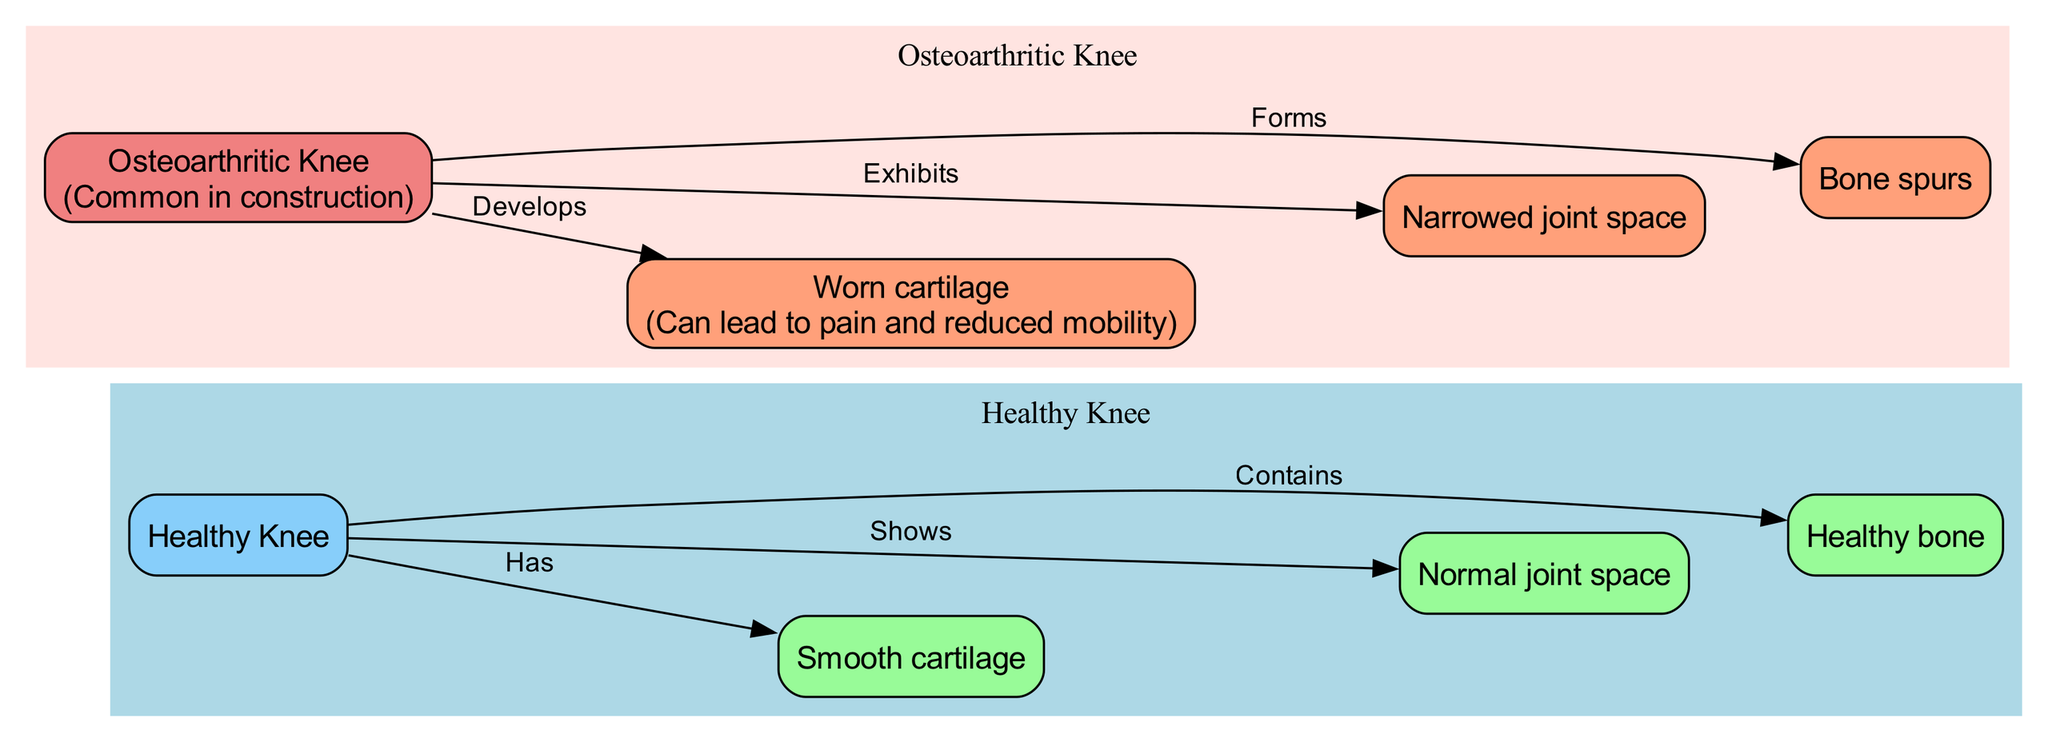What does the healthy knee contain? The diagram indicates that the healthy knee contains healthy bone, represented by the connection from "Healthy Knee" to "Healthy bone" that states "Contains".
Answer: Healthy bone What condition does an osteoarthritic knee develop? The diagram shows that the osteoarthritic knee develops worn cartilage, represented by the relationship from "Osteoarthritic Knee" to "Worn cartilage" that states "Develops".
Answer: Worn cartilage What is the joint space like in a healthy knee? The diagram indicates that the joint space in a healthy knee is normal, as shown by the connection from "Healthy Knee" to "Normal joint space" which states "Shows".
Answer: Normal joint space What forms in an osteoarthritic knee? In the diagram, it is indicated that bone spurs form in an osteoarthritic knee, as shown by the relationship from "Osteoarthritic Knee" to "Bone spurs" that states "Forms".
Answer: Bone spurs How many nodes are present in the diagram? By counting the unique nodes described in the diagram, there are a total of 8 nodes, representing both healthy and osteoarthritic knee components.
Answer: 8 What distinguishes the joint space of osteoarthritic knee from the healthy knee? The diagram indicates that the joint space in the osteoarthritic knee is narrowed, in contrast to the healthy knee which shows a normal joint space. This comparison shows a significant difference between the two states.
Answer: Narrowed joint space What are the implications of damaged cartilage? According to the annotation in the diagram, damaged cartilage can lead to pain and reduced mobility, indicating the functional consequences of the degradation observed in osteoarthritis.
Answer: Pain and reduced mobility What is common in construction workers according to the diagram? The diagram notes that osteoarthritis is common in construction workers, explicitly highlighted in an annotation tied to the "Osteoarthritic Knee" node.
Answer: Common in construction 